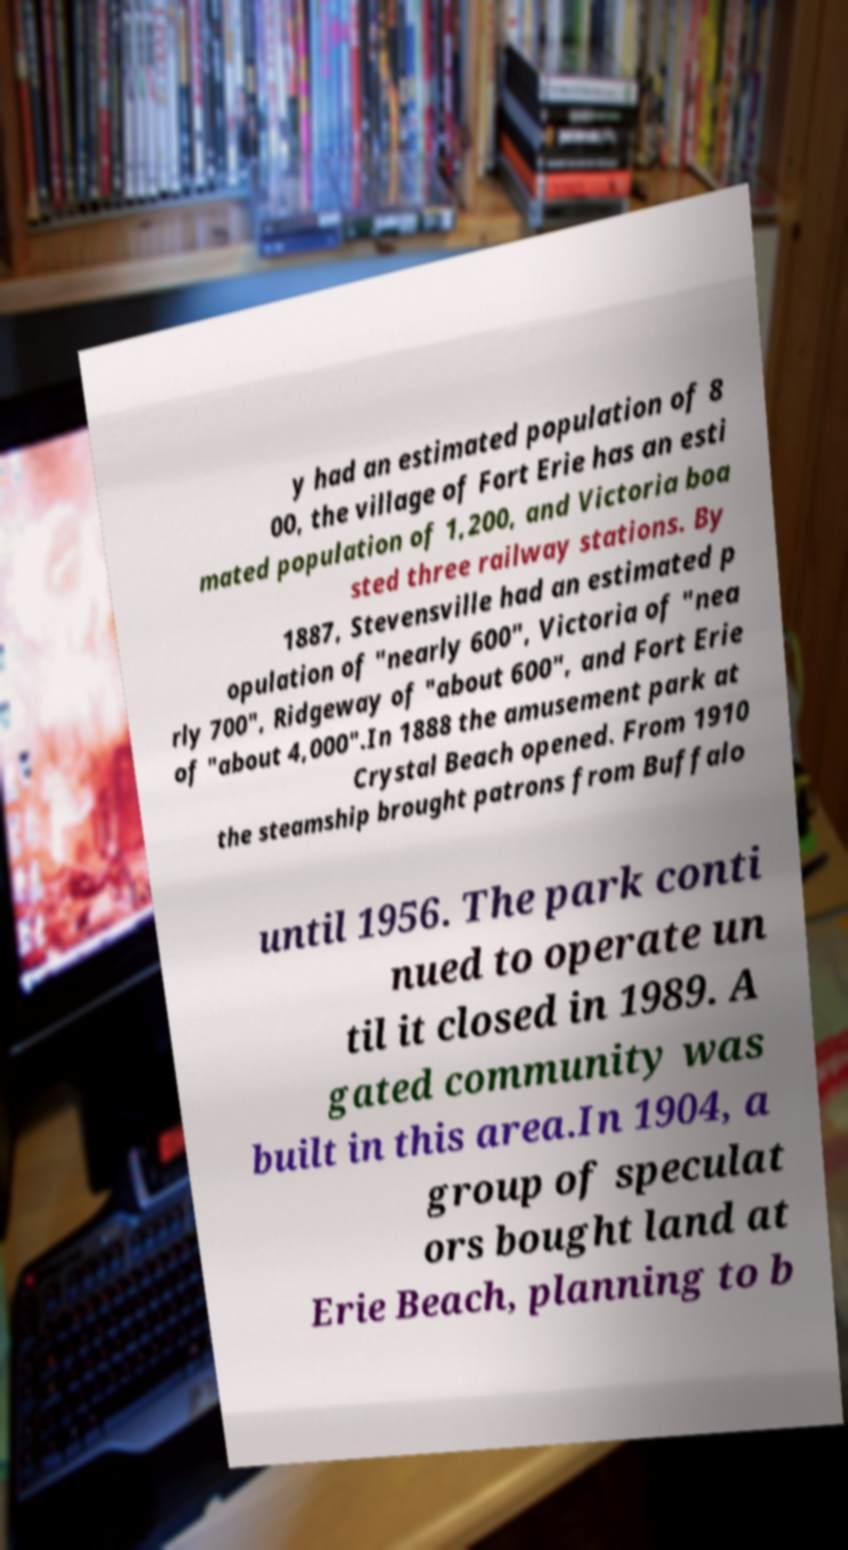Could you assist in decoding the text presented in this image and type it out clearly? y had an estimated population of 8 00, the village of Fort Erie has an esti mated population of 1,200, and Victoria boa sted three railway stations. By 1887, Stevensville had an estimated p opulation of "nearly 600", Victoria of "nea rly 700", Ridgeway of "about 600", and Fort Erie of "about 4,000".In 1888 the amusement park at Crystal Beach opened. From 1910 the steamship brought patrons from Buffalo until 1956. The park conti nued to operate un til it closed in 1989. A gated community was built in this area.In 1904, a group of speculat ors bought land at Erie Beach, planning to b 